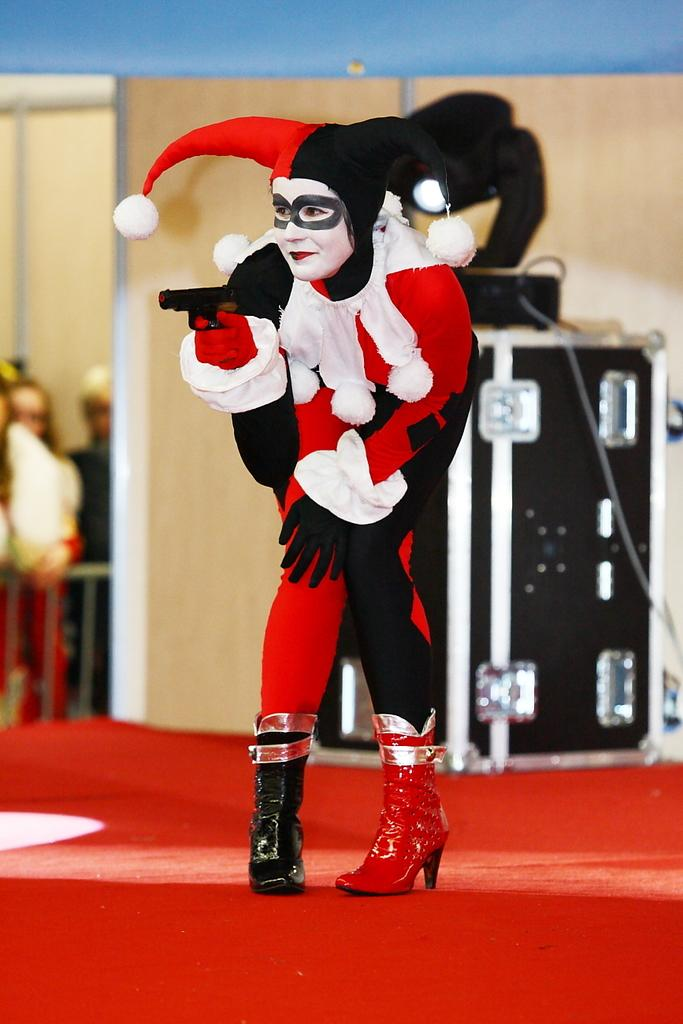What is the main subject on the dais in the image? There is a human on a dais in the image. What object can be seen near the human on the dais? There is a box visible in the image. Who else is present in the image besides the human on the dais? There are people standing near the dais. What is the human holding in the image? There is a human holding a gun in the image. How many twigs are being used to play the drum in the image? There is no drum or twigs present in the image. What type of number is being displayed on the box in the image? There is no number displayed on the box in the image. 